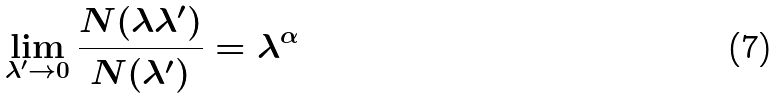Convert formula to latex. <formula><loc_0><loc_0><loc_500><loc_500>\lim _ { \lambda ^ { \prime } \to 0 } \frac { N ( \lambda \lambda ^ { \prime } ) } { N ( \lambda ^ { \prime } ) } = \lambda ^ { \alpha }</formula> 